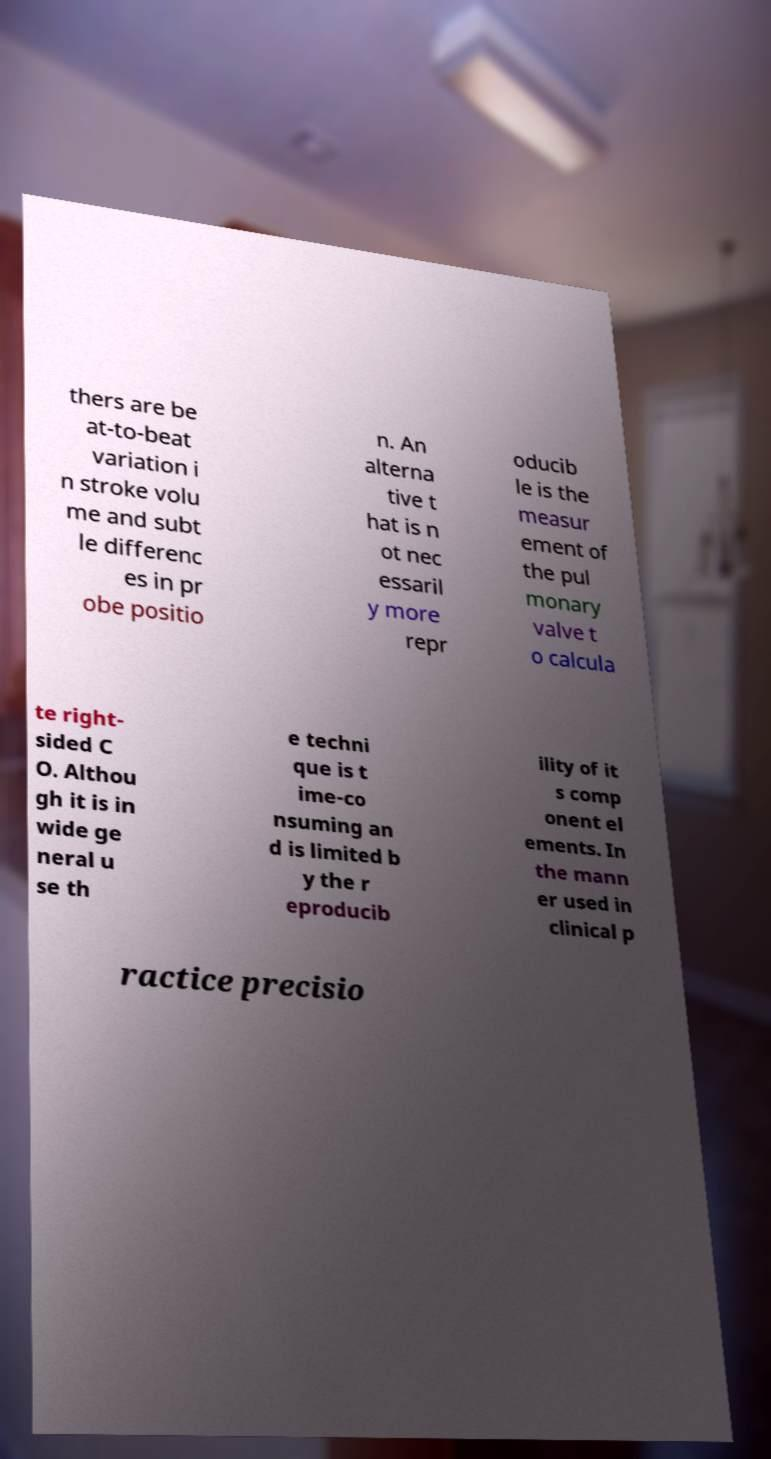What messages or text are displayed in this image? I need them in a readable, typed format. thers are be at-to-beat variation i n stroke volu me and subt le differenc es in pr obe positio n. An alterna tive t hat is n ot nec essaril y more repr oducib le is the measur ement of the pul monary valve t o calcula te right- sided C O. Althou gh it is in wide ge neral u se th e techni que is t ime-co nsuming an d is limited b y the r eproducib ility of it s comp onent el ements. In the mann er used in clinical p ractice precisio 